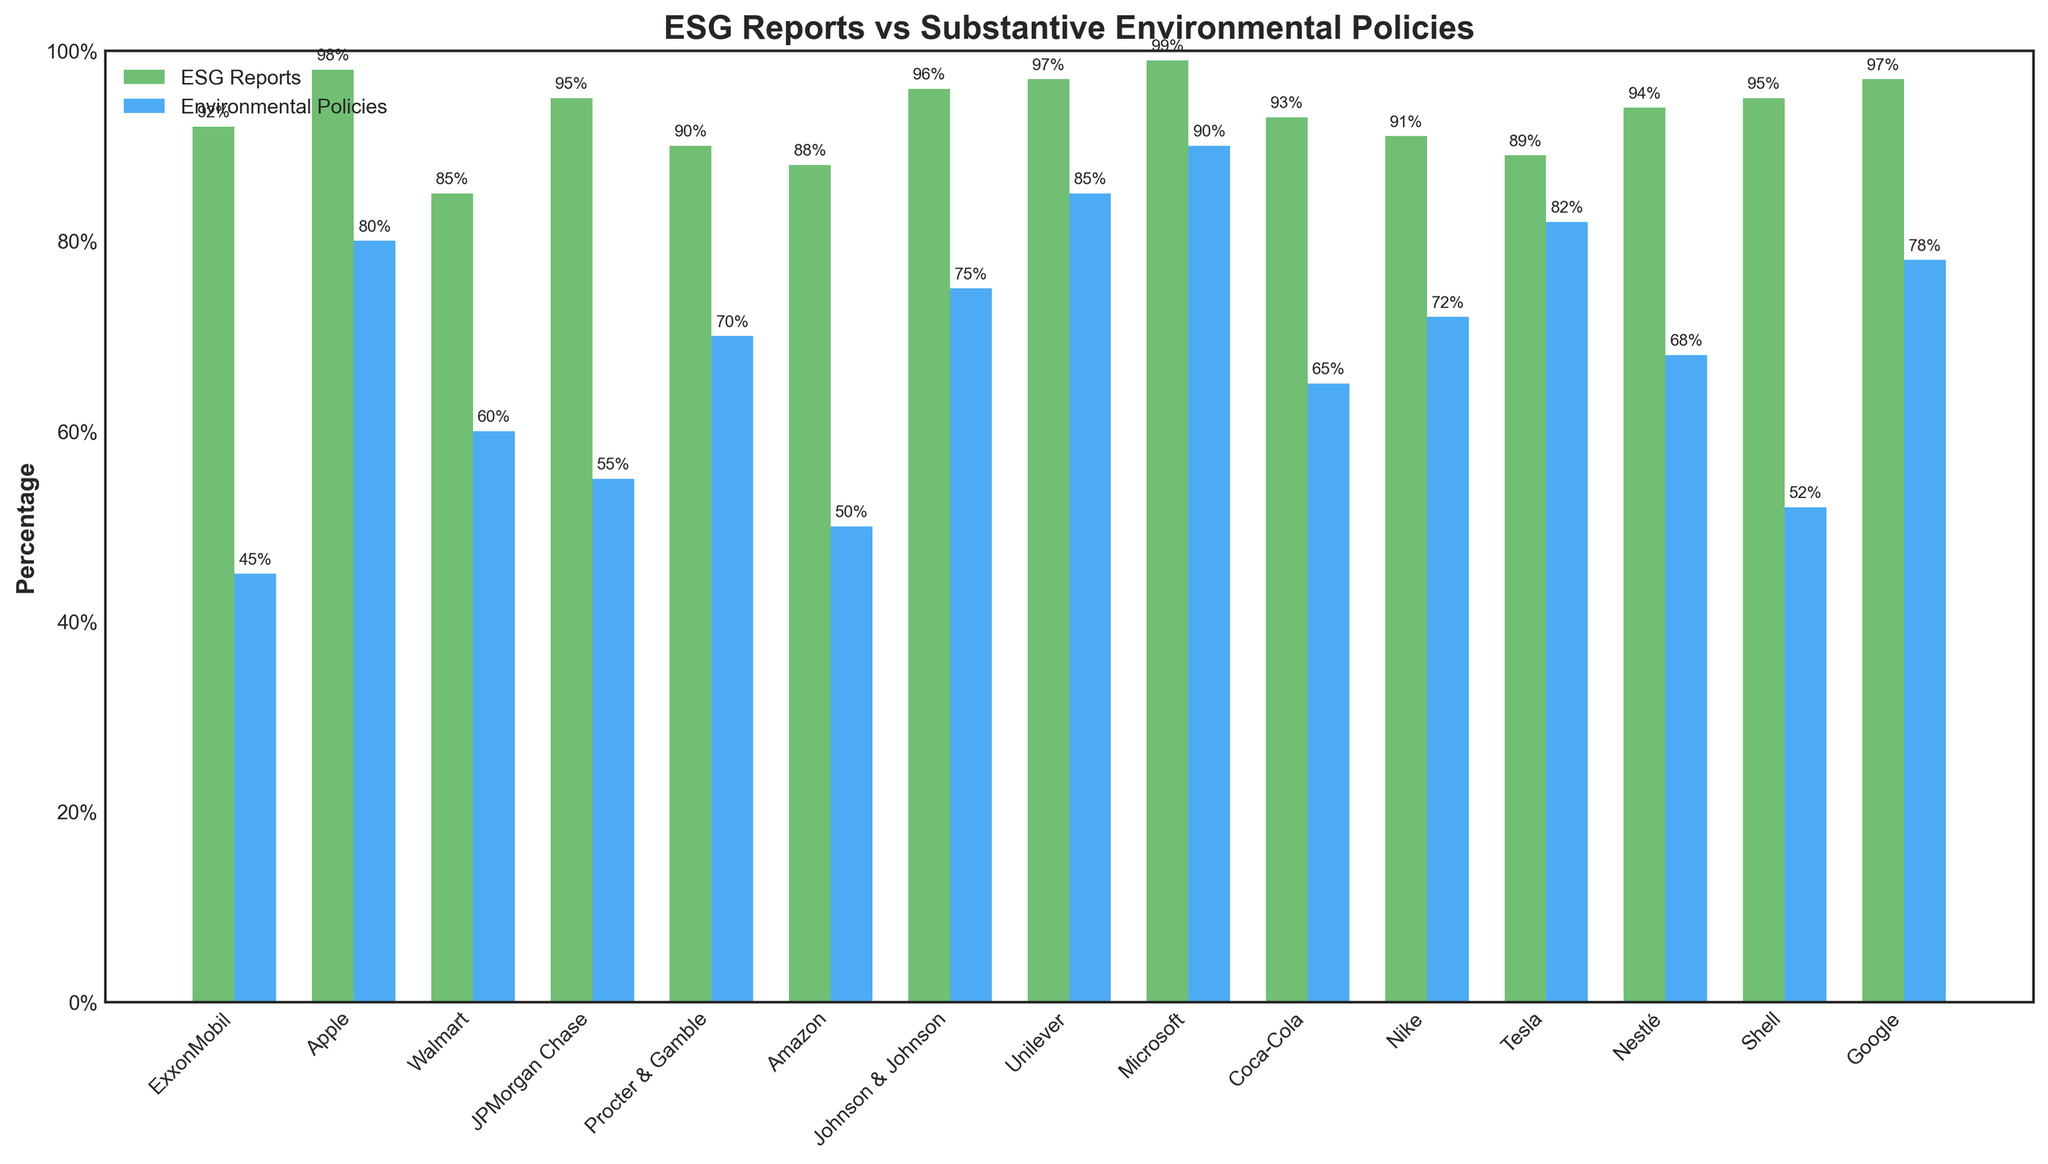Which company has the highest percentage of ESG reports and what is that percentage? By identifying the tallest green bar, which indicates the percentage of ESG reports, we see that Microsoft has the highest percentage.
Answer: Microsoft, 99% Which company has the smallest difference between its ESG reports and substantive environmental policies? Calculate the difference between the two bars for each company and identify the smallest absolute difference. The difference for ExxonMobil is 92 - 45 = 47, Apple is 98 - 80 = 18, Walmart is 85 - 60 = 25, and so on. The smallest difference is for Apple at 18%.
Answer: Apple, 18% How many companies have at least 90% of ESG reports? Count the green bars that reach at least 90% on the y-axis. The companies that qualify are: ExxonMobil, Apple, JPMorgan Chase, Procter & Gamble, Johnson & Johnson, Unilever, Microsoft, Coca-Cola, Nike, Nestlé, Shell, and Google.
Answer: 12 Which company has a higher percentage of substantive environmental policies, Tesla or Unilever? Look at the blue bars representing Tesla and Unilever and compare their heights. Tesla has 82% while Unilever has 85%.
Answer: Unilever What is the average percentage of substantive environmental policies among all companies? Sum the percentages of substantive environmental policies for all companies and divide by the number of companies. (45 + 80 + 60 + 55 + 70 + 50 + 75 + 85 + 90 + 65 + 72 + 82 + 68 + 52 + 78) / 15 = 69.
Answer: 69 Which color represents the percentage of substantive environmental policies in the bar chart? Identify the color of the bars labeled as "Environmental Policies." The blue bars represent substantive environmental policies.
Answer: Blue Which company shows a significant discrepancy—with a difference of more than 40%—between ESG reports and substantive environmental policies? Calculate the absolute differences and identify any company with a difference greater than 40%. ExxonMobil shows a discrepancy of 47% (92 - 45 = 47).
Answer: ExxonMobil Which companies have more than 70% of substantive environmental policies? Identify the blue bars that are taller than 70%. These companies are Apple (80%), Procter & Gamble (70%), Johnson & Johnson (75%), Unilever (85%), Microsoft (90%), Nike (72%), and Tesla (82%).
Answer: 7 